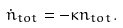<formula> <loc_0><loc_0><loc_500><loc_500>\dot { n } _ { t o t } = - \kappa n _ { t o t } .</formula> 